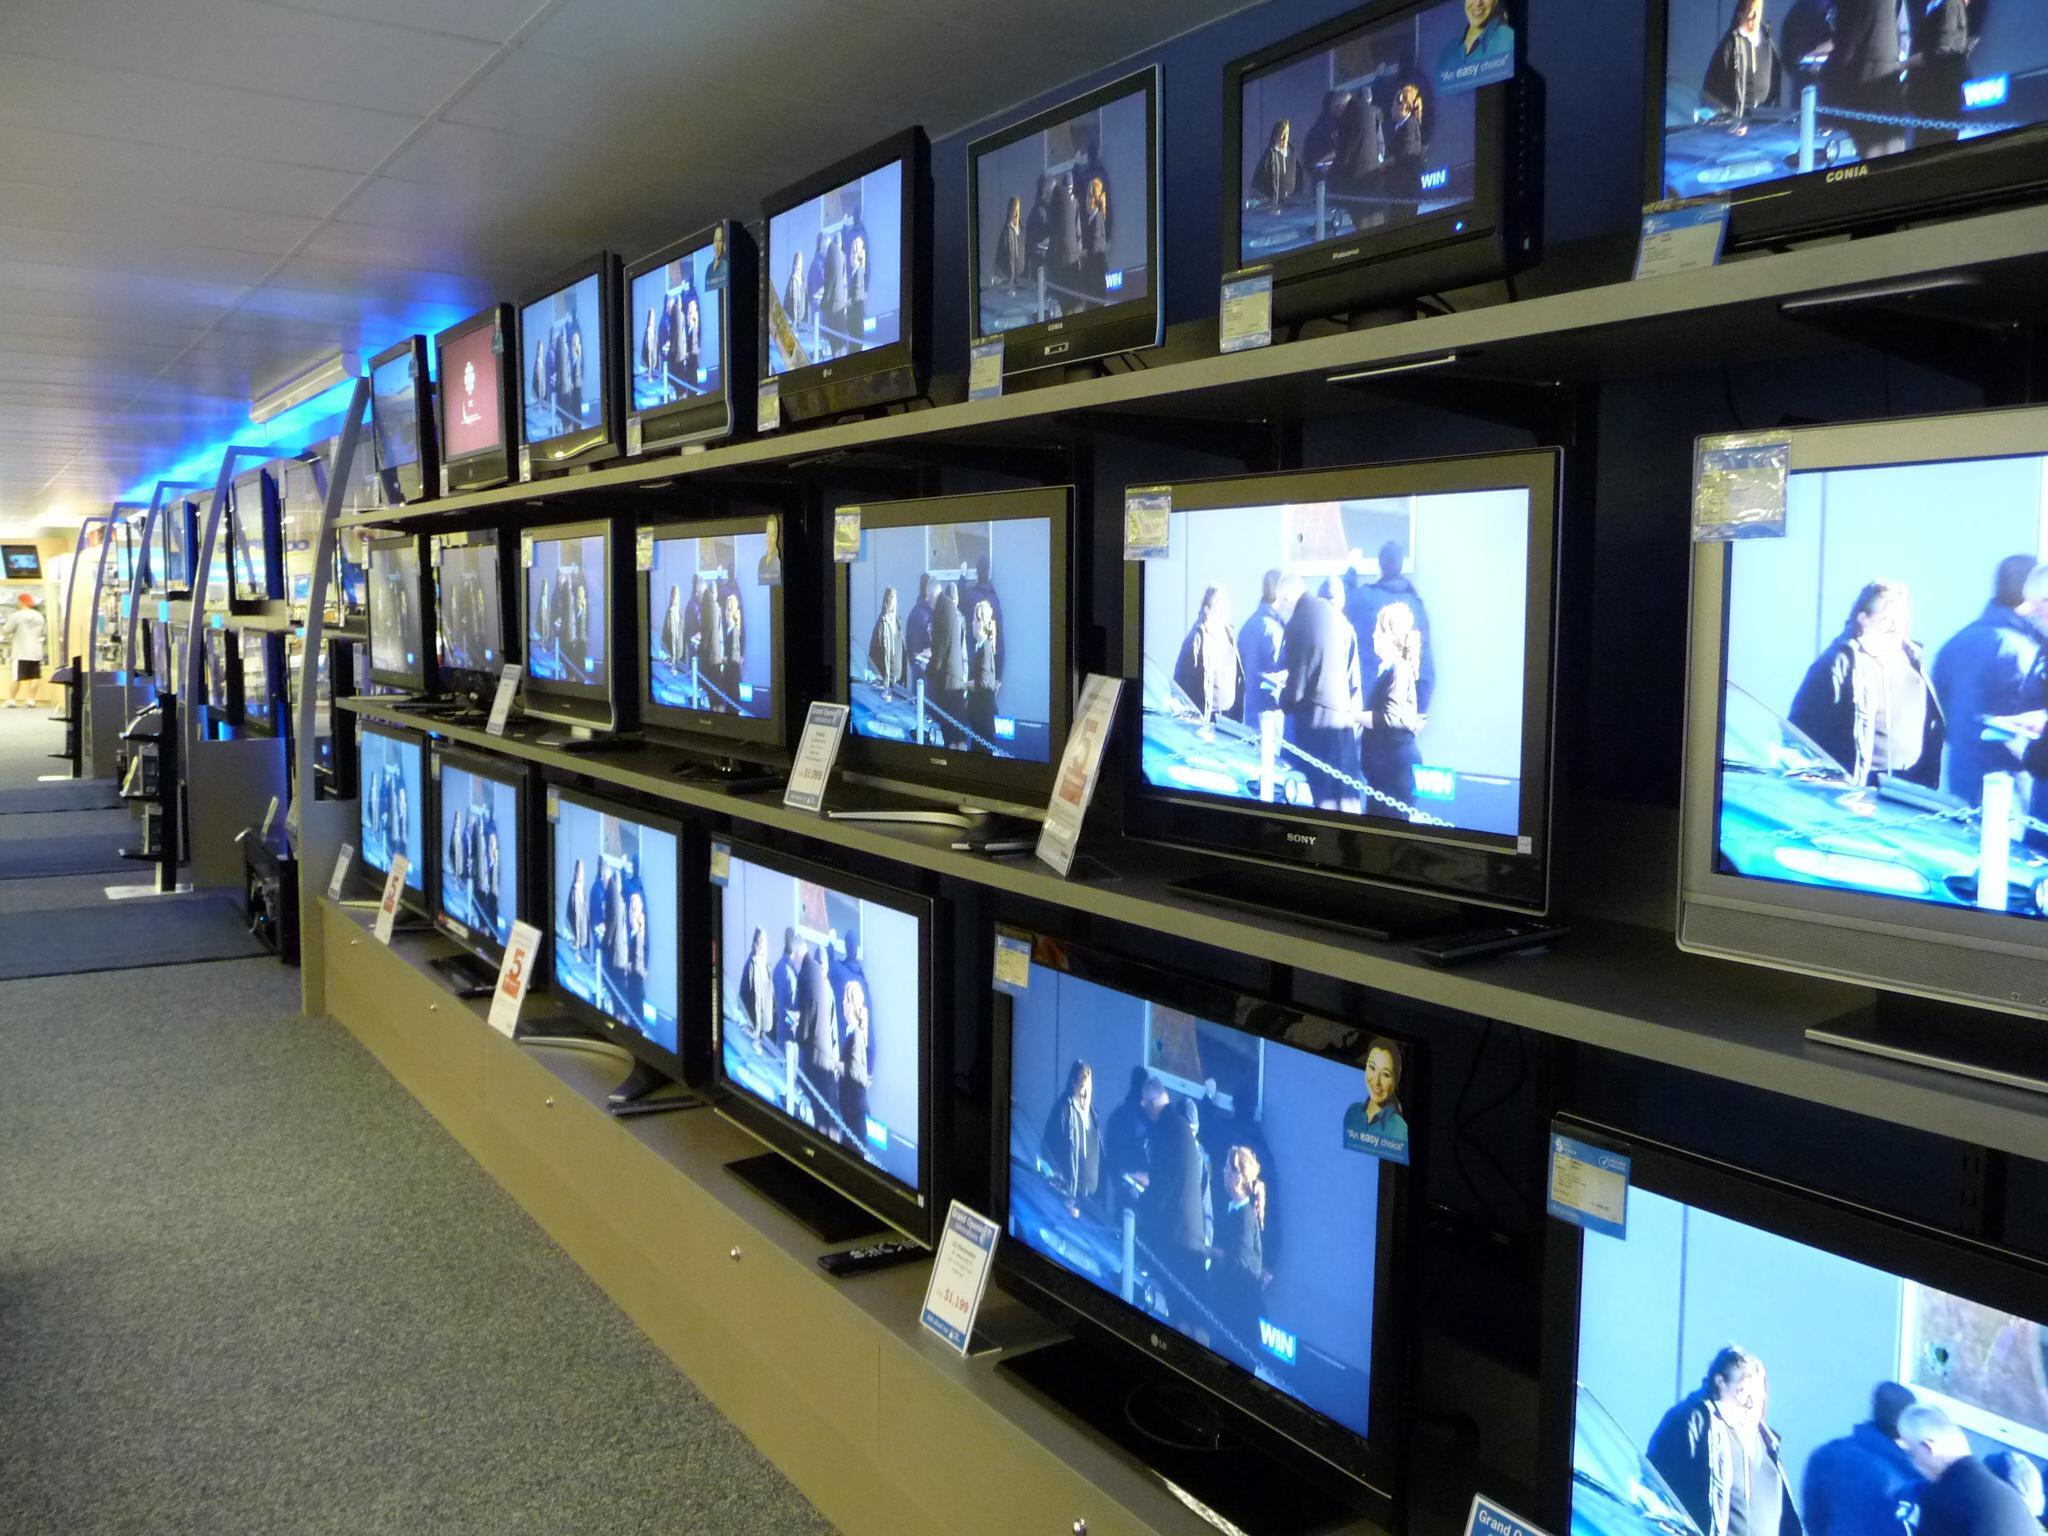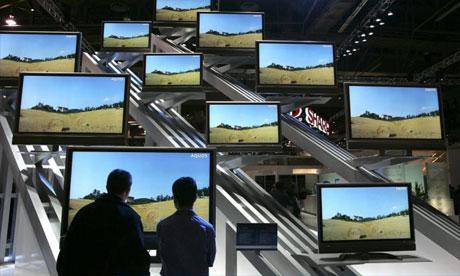The first image is the image on the left, the second image is the image on the right. For the images shown, is this caption "The right image contains two humans." true? Answer yes or no. Yes. 